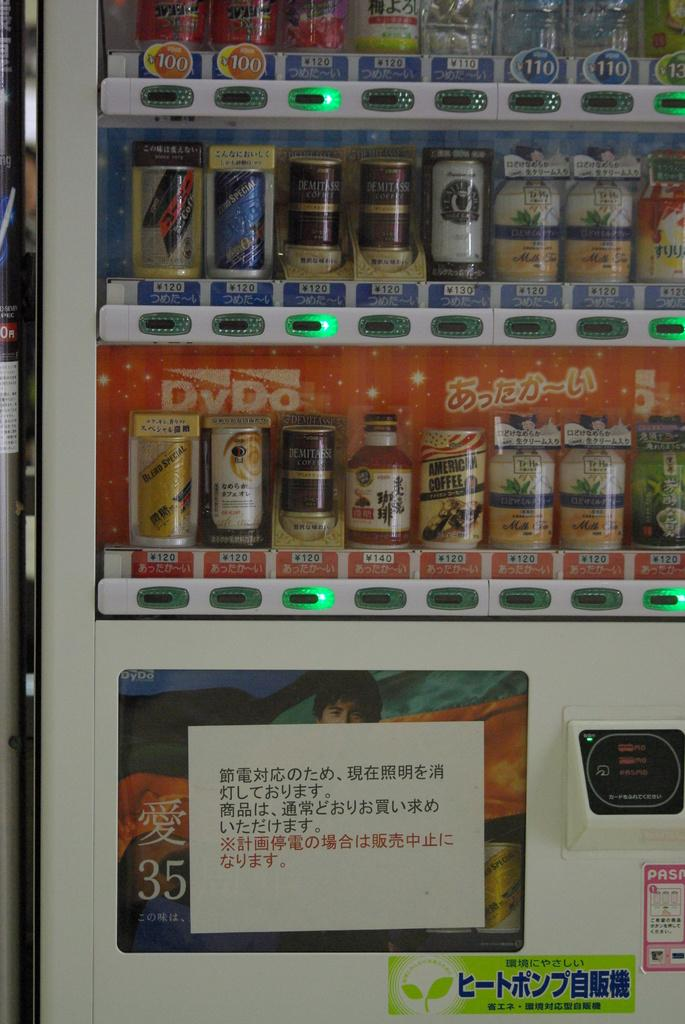<image>
Provide a brief description of the given image. A vending machine says DyDo on the back. 